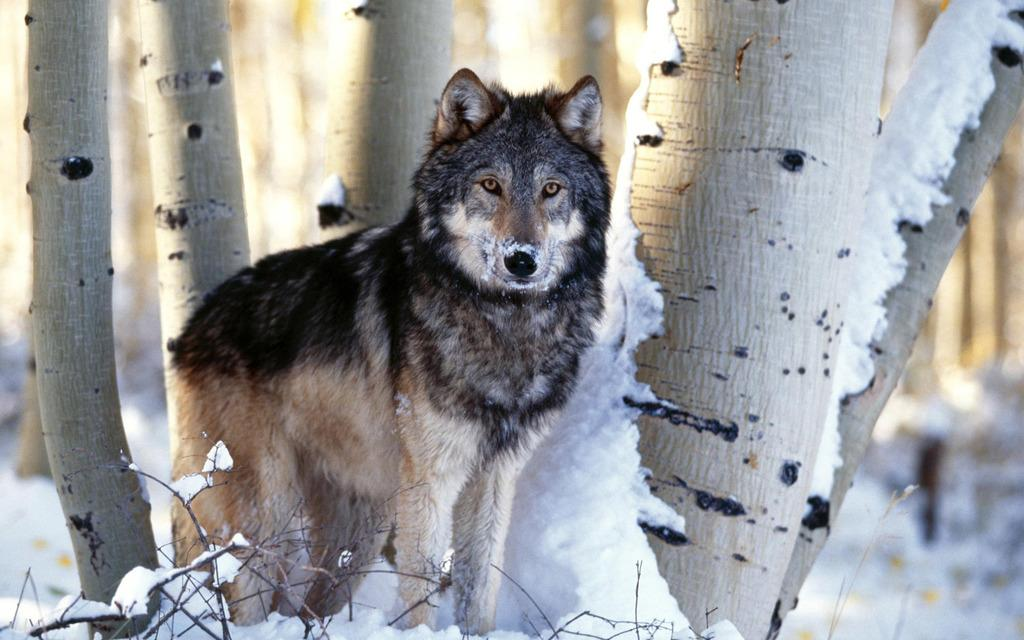What can be seen in the background of the image? There are tree trunks in the background of the image. What type of weather condition is depicted in the image? Snow is present at the bottom portion of the image, indicating a winter scene. What other objects are visible at the bottom portion of the image? Twigs are visible at the bottom portion of the image. What is the main subject of the image? The main focus of the image is a wolf. Reasoning: Let' Let's think step by step in order to produce the conversation. We start by identifying the background elements of the image, which include tree trunks. Then, we describe the weather condition by mentioning the presence of snow. Next, we include other objects visible at the bottom portion of the image, which are twigs. Finally, we identify the main subject of the image, which is a wolf. Absurd Question/Answer: Is the wolf fighting with its brother in the image? There is no indication of a fight or a brother in the image; it simply shows a wolf in a winter setting with tree trunks, snow, and twigs. How many trees are the wolf and its brother climbing in the image? There is no tree present in the image, and no mention of a brother. The wolf is the main focus, and it is not climbing any trees. 